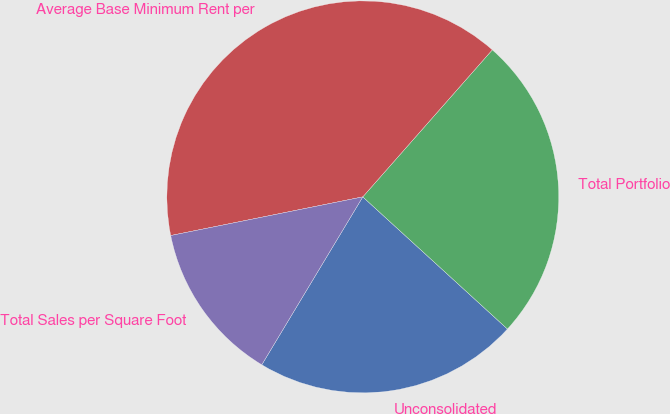Convert chart to OTSL. <chart><loc_0><loc_0><loc_500><loc_500><pie_chart><fcel>Unconsolidated<fcel>Total Portfolio<fcel>Average Base Minimum Rent per<fcel>Total Sales per Square Foot<nl><fcel>21.84%<fcel>25.29%<fcel>39.66%<fcel>13.22%<nl></chart> 